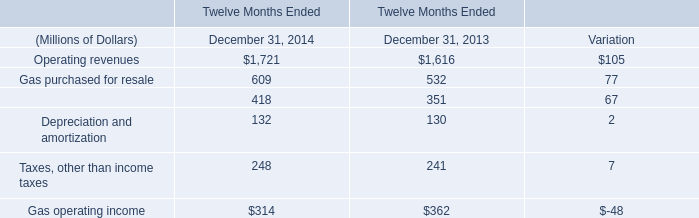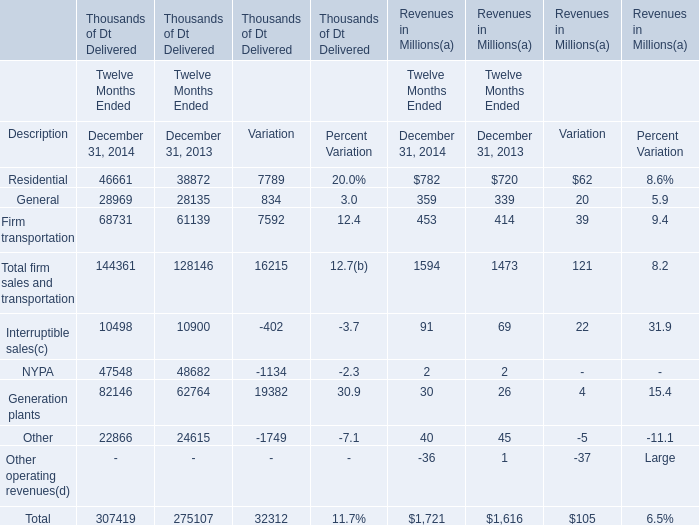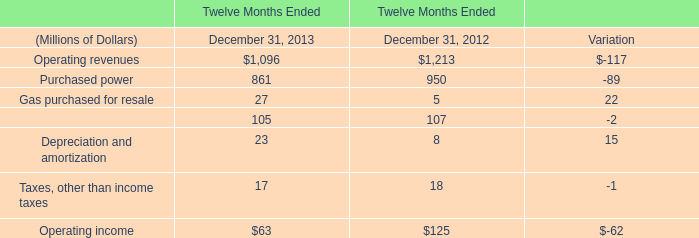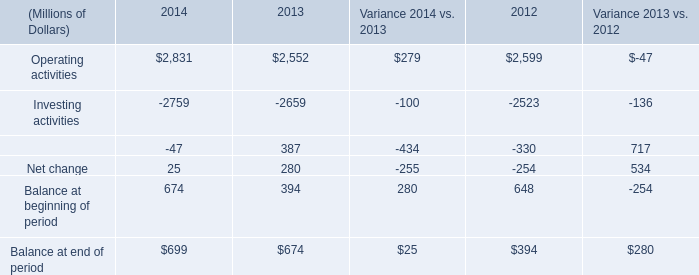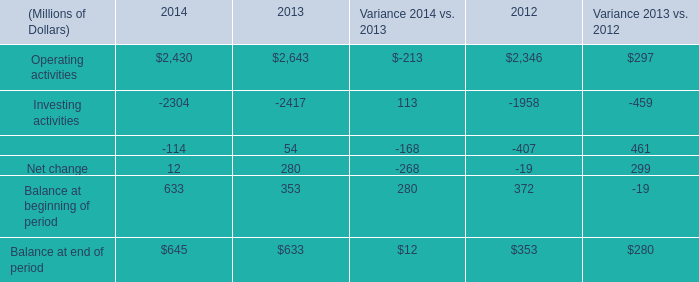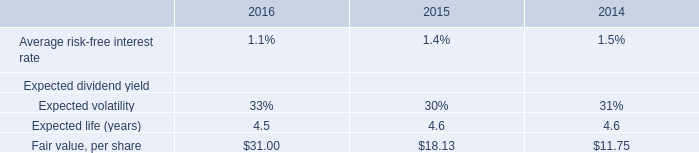what is the value , in millions of dollars , of the total issuable stock in 2014? 
Computations: (13.8 * 11.75)
Answer: 162.15. 